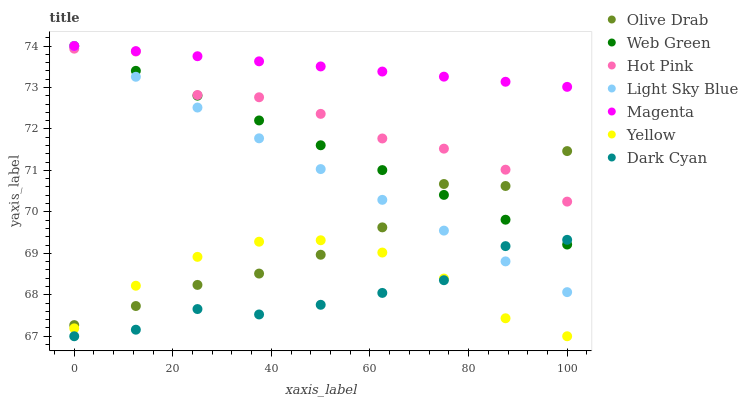Does Dark Cyan have the minimum area under the curve?
Answer yes or no. Yes. Does Magenta have the maximum area under the curve?
Answer yes or no. Yes. Does Yellow have the minimum area under the curve?
Answer yes or no. No. Does Yellow have the maximum area under the curve?
Answer yes or no. No. Is Web Green the smoothest?
Answer yes or no. Yes. Is Hot Pink the roughest?
Answer yes or no. Yes. Is Yellow the smoothest?
Answer yes or no. No. Is Yellow the roughest?
Answer yes or no. No. Does Yellow have the lowest value?
Answer yes or no. Yes. Does Light Sky Blue have the lowest value?
Answer yes or no. No. Does Magenta have the highest value?
Answer yes or no. Yes. Does Yellow have the highest value?
Answer yes or no. No. Is Yellow less than Web Green?
Answer yes or no. Yes. Is Magenta greater than Dark Cyan?
Answer yes or no. Yes. Does Hot Pink intersect Light Sky Blue?
Answer yes or no. Yes. Is Hot Pink less than Light Sky Blue?
Answer yes or no. No. Is Hot Pink greater than Light Sky Blue?
Answer yes or no. No. Does Yellow intersect Web Green?
Answer yes or no. No. 